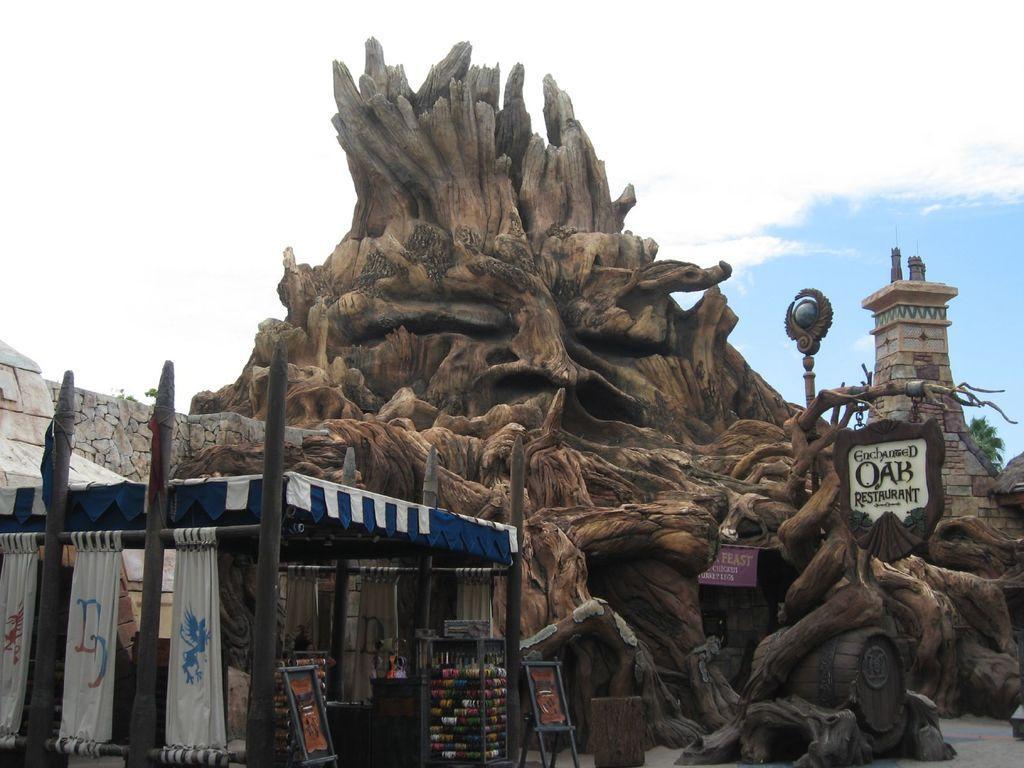Can you describe this image briefly? In the center of the image, we can see a wooden structure and we can see boards with some text and there are curtains, a tent, poles and we can see some other stands and there is a building, a rock wall and a tree. 